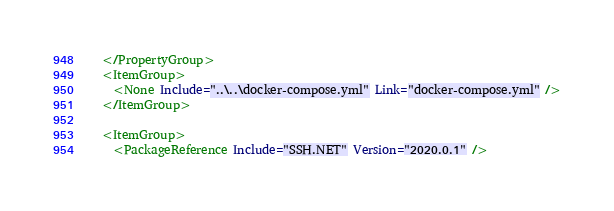Convert code to text. <code><loc_0><loc_0><loc_500><loc_500><_XML_>  </PropertyGroup>
  <ItemGroup>
    <None Include="..\..\docker-compose.yml" Link="docker-compose.yml" />
  </ItemGroup>

  <ItemGroup>
    <PackageReference Include="SSH.NET" Version="2020.0.1" /></code> 